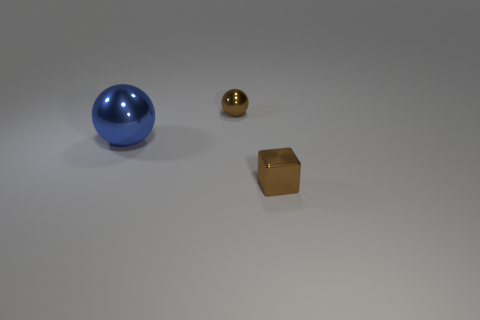There is a small metal block; does it have the same color as the metallic sphere that is behind the blue metal ball?
Your answer should be very brief. Yes. What is the shape of the tiny brown thing that is in front of the ball behind the large blue shiny thing?
Your response must be concise. Cube. There is a thing that is on the right side of the tiny brown ball; what color is it?
Give a very brief answer. Brown. What material is the cube that is the same color as the small ball?
Your response must be concise. Metal. Are there any large blue objects in front of the brown shiny sphere?
Give a very brief answer. Yes. Is the number of large metal balls greater than the number of tiny red blocks?
Give a very brief answer. Yes. There is a shiny ball that is right of the sphere that is to the left of the sphere behind the large blue metallic thing; what color is it?
Your answer should be very brief. Brown. What color is the big object that is the same material as the small brown ball?
Your answer should be compact. Blue. Is there any other thing that has the same size as the blue metal thing?
Offer a terse response. No. What number of objects are either objects to the left of the brown metallic cube or brown metal objects that are to the left of the tiny brown shiny block?
Give a very brief answer. 2. 